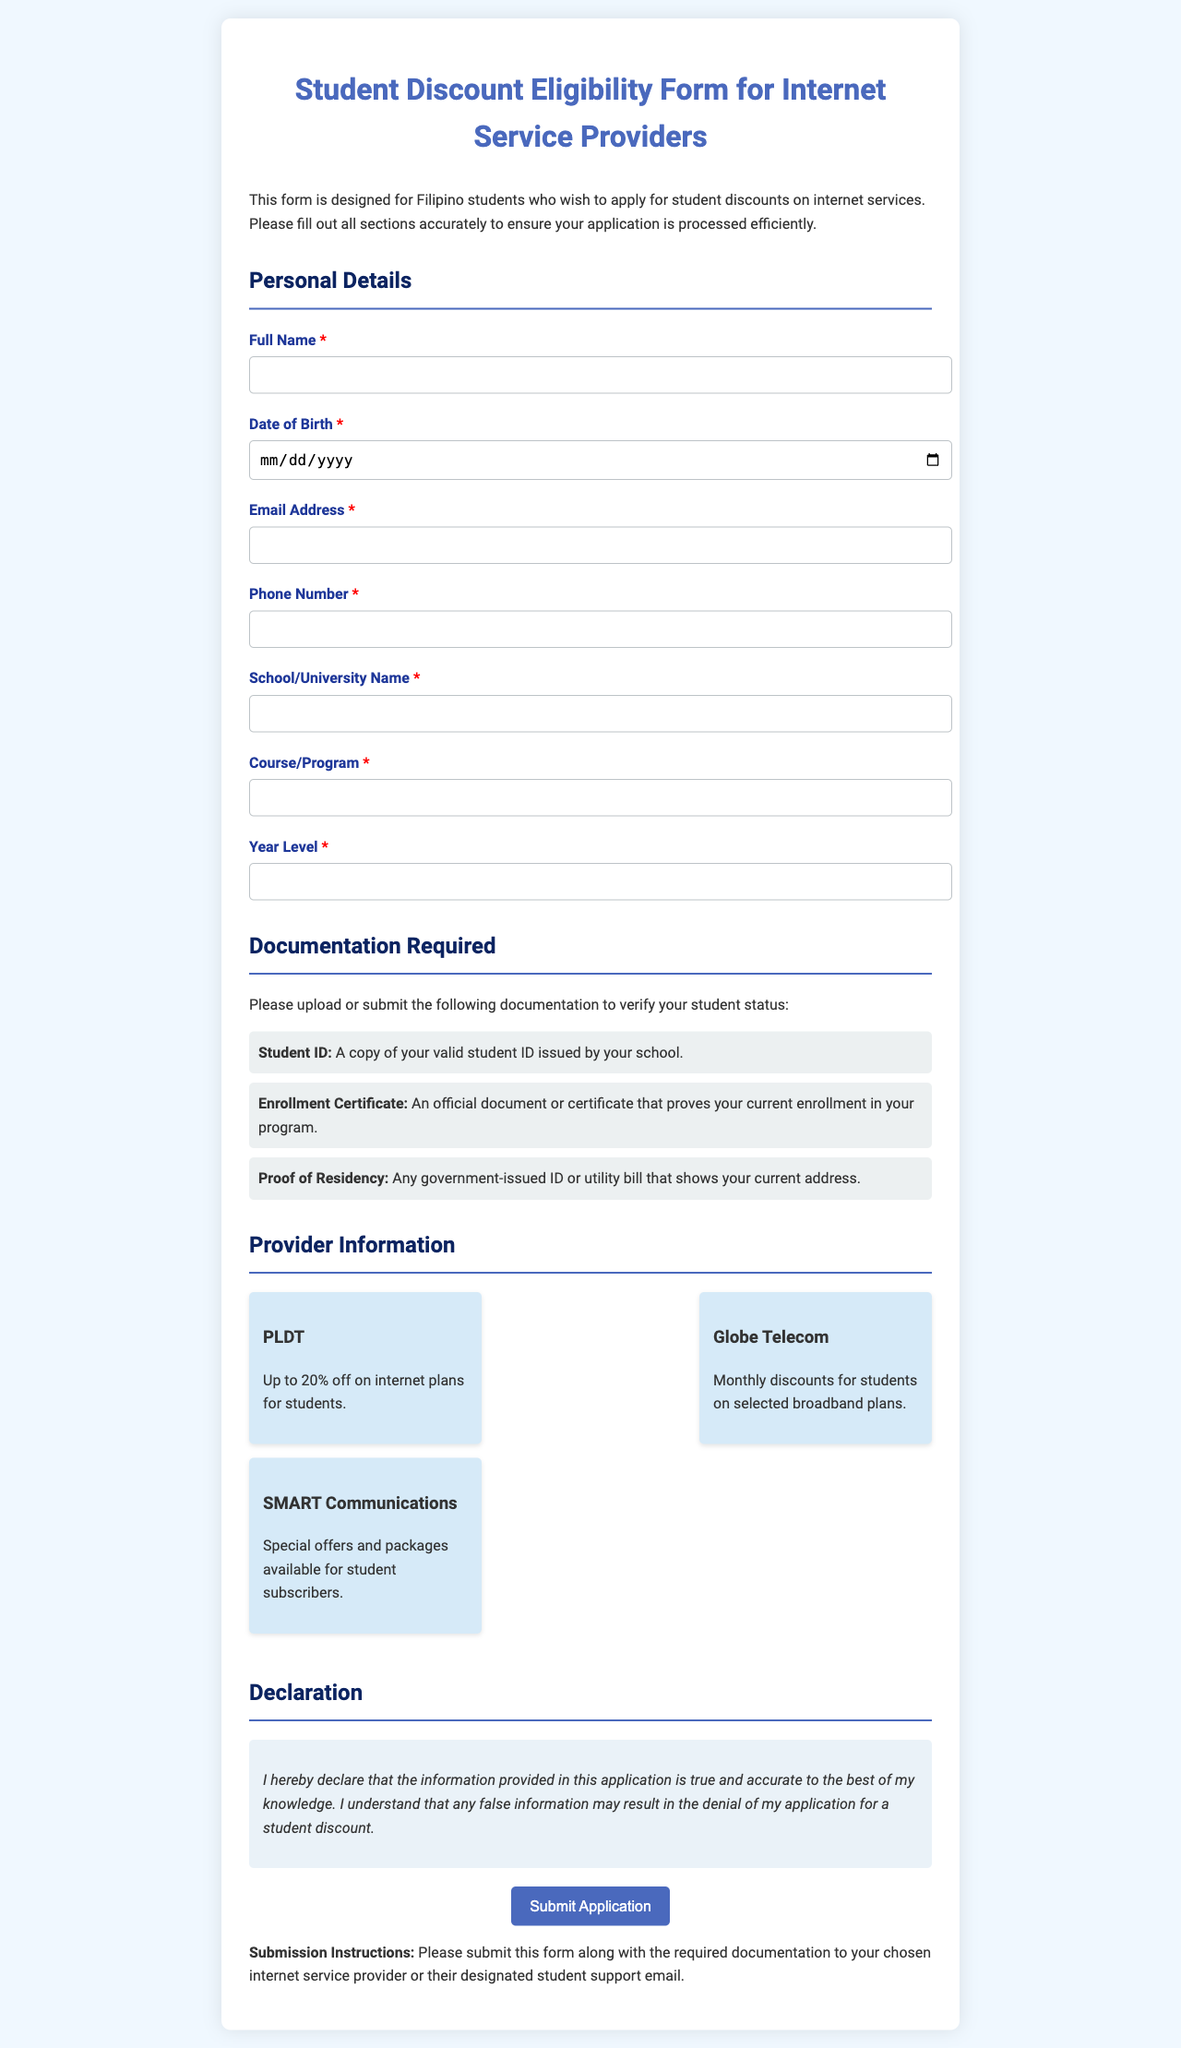what is the title of the form? The title of the form is stated at the top of the document, indicating its purpose for eligible students.
Answer: Student Discount Eligibility Form for Internet Service Providers who is this form designed for? The introductory paragraph clarifies the target audience for the form application.
Answer: Filipino students what is a required document for verification? The section on documentation lists specific items that must be submitted to verify student status.
Answer: Student ID how many internet service providers are mentioned? The provider information section lists all available options for students seeking discounts.
Answer: 3 what discount does PLDT offer students? The provider section specifies the discount rates available for students under each internet service provider.
Answer: Up to 20% off what is required to prove current enrollment? The documentation section states what students need to submit as proof of their status in their educational program.
Answer: Enrollment Certificate what does the declaration statement imply? The declaration section outlines the student's responsibility concerning the accuracy of the provided information in their application.
Answer: True and accurate information what should be done with the form after completion? The submission instructions provide clear guidance on what to do once the form is filled out with the necessary documents.
Answer: Submit to chosen internet service provider 